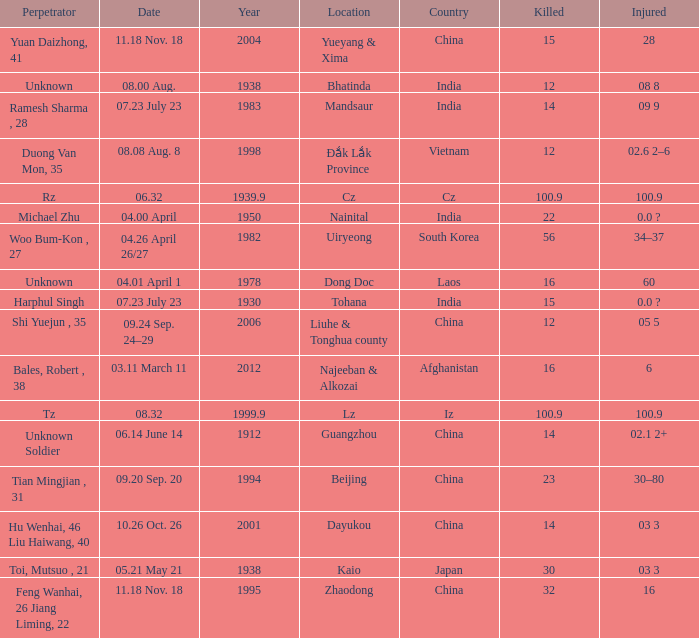What is Country, when Killed is "100.9", and when Year is greater than 1939.9? Iz. Could you parse the entire table as a dict? {'header': ['Perpetrator', 'Date', 'Year', 'Location', 'Country', 'Killed', 'Injured'], 'rows': [['Yuan Daizhong, 41', '11.18 Nov. 18', '2004', 'Yueyang & Xima', 'China', '15', '28'], ['Unknown', '08.00 Aug.', '1938', 'Bhatinda', 'India', '12', '08 8'], ['Ramesh Sharma , 28', '07.23 July 23', '1983', 'Mandsaur', 'India', '14', '09 9'], ['Duong Van Mon, 35', '08.08 Aug. 8', '1998', 'Đắk Lắk Province', 'Vietnam', '12', '02.6 2–6'], ['Rz', '06.32', '1939.9', 'Cz', 'Cz', '100.9', '100.9'], ['Michael Zhu', '04.00 April', '1950', 'Nainital', 'India', '22', '0.0 ?'], ['Woo Bum-Kon , 27', '04.26 April 26/27', '1982', 'Uiryeong', 'South Korea', '56', '34–37'], ['Unknown', '04.01 April 1', '1978', 'Dong Doc', 'Laos', '16', '60'], ['Harphul Singh', '07.23 July 23', '1930', 'Tohana', 'India', '15', '0.0 ?'], ['Shi Yuejun , 35', '09.24 Sep. 24–29', '2006', 'Liuhe & Tonghua county', 'China', '12', '05 5'], ['Bales, Robert , 38', '03.11 March 11', '2012', 'Najeeban & Alkozai', 'Afghanistan', '16', '6'], ['Tz', '08.32', '1999.9', 'Lz', 'Iz', '100.9', '100.9'], ['Unknown Soldier', '06.14 June 14', '1912', 'Guangzhou', 'China', '14', '02.1 2+'], ['Tian Mingjian , 31', '09.20 Sep. 20', '1994', 'Beijing', 'China', '23', '30–80'], ['Hu Wenhai, 46 Liu Haiwang, 40', '10.26 Oct. 26', '2001', 'Dayukou', 'China', '14', '03 3'], ['Toi, Mutsuo , 21', '05.21 May 21', '1938', 'Kaio', 'Japan', '30', '03 3'], ['Feng Wanhai, 26 Jiang Liming, 22', '11.18 Nov. 18', '1995', 'Zhaodong', 'China', '32', '16']]} 